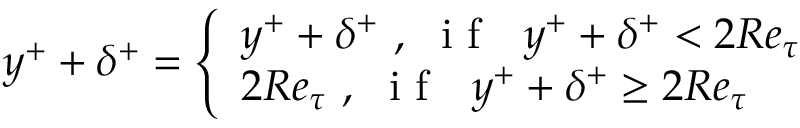Convert formula to latex. <formula><loc_0><loc_0><loc_500><loc_500>y ^ { + } + \delta ^ { + } = \left \{ \begin{array} { l l } { y ^ { + } + \delta ^ { + } , i f y ^ { + } + \delta ^ { + } < 2 R e _ { \tau } } \\ { 2 R e _ { \tau } , i f y ^ { + } + \delta ^ { + } \geq 2 R e _ { \tau } } \end{array}</formula> 